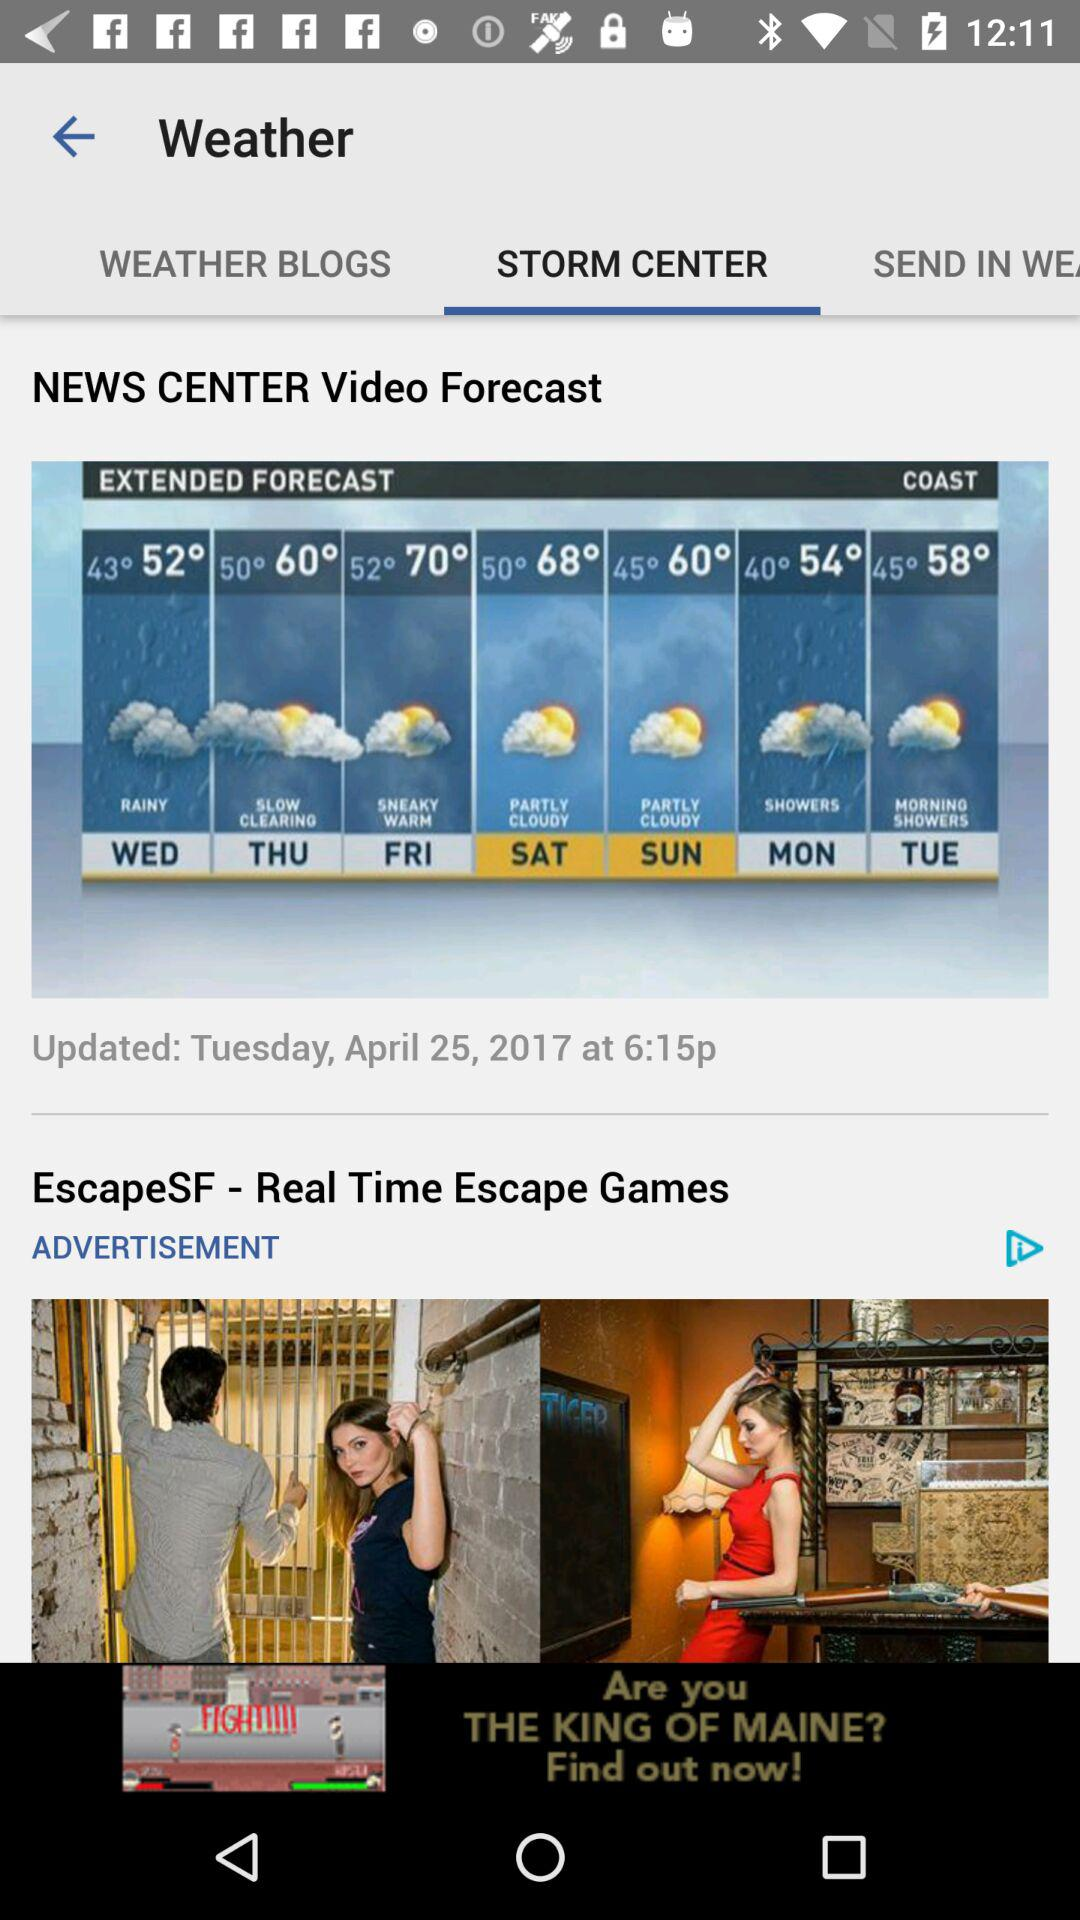How is the weather going to be on Friday? The weather is going to be sneaky warm on Friday. 